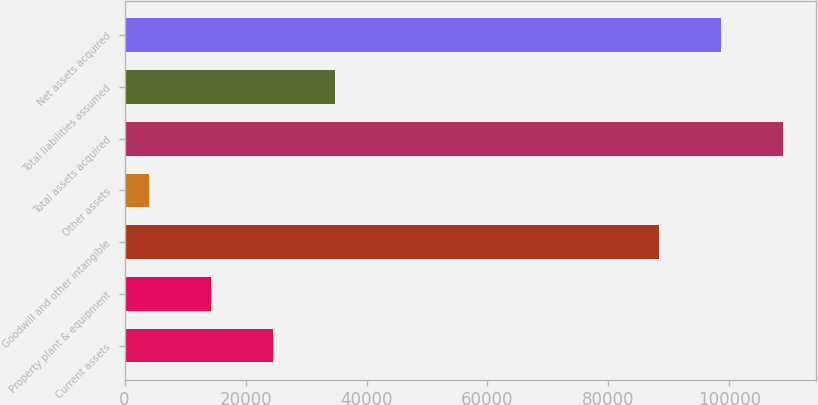<chart> <loc_0><loc_0><loc_500><loc_500><bar_chart><fcel>Current assets<fcel>Property plant & equipment<fcel>Goodwill and other intangible<fcel>Other assets<fcel>Total assets acquired<fcel>Total liabilities assumed<fcel>Net assets acquired<nl><fcel>24558.6<fcel>14292.8<fcel>88337<fcel>4027<fcel>108869<fcel>34824.4<fcel>98602.8<nl></chart> 